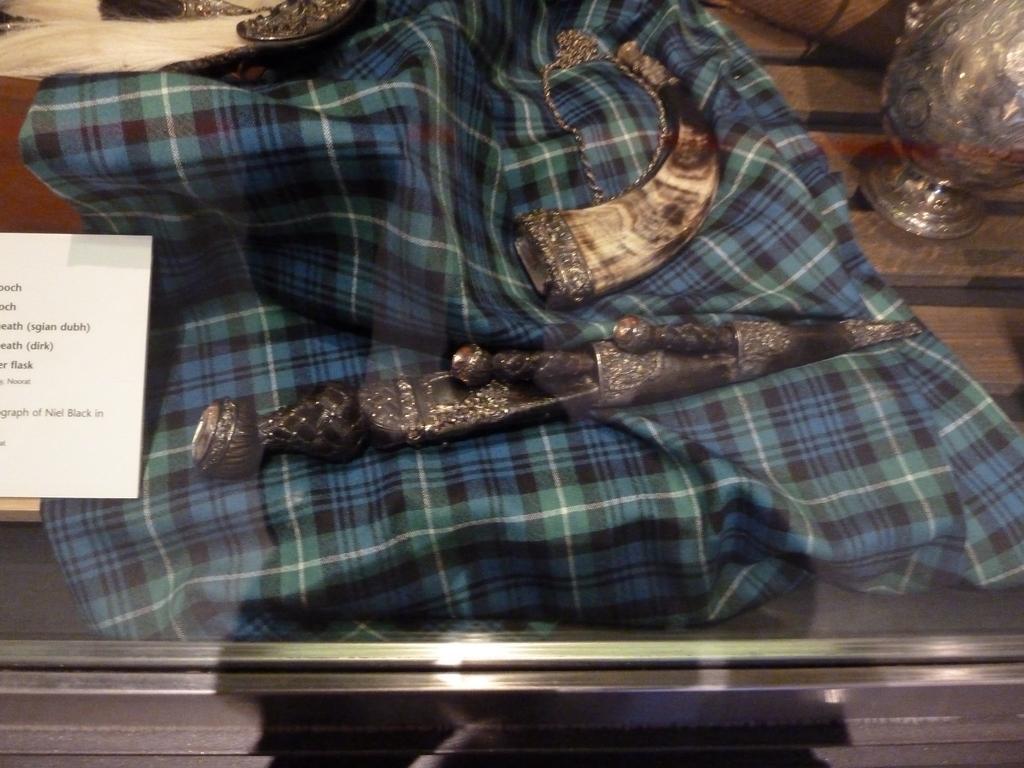Could you give a brief overview of what you see in this image? In this picture there are few objects placed on a cloth and there is a paper which has something written on it in the left corner and there are some other objects in the right corner. 